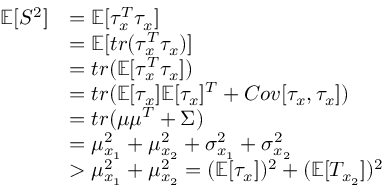<formula> <loc_0><loc_0><loc_500><loc_500>\begin{array} { r l } { \mathbb { E } [ S ^ { 2 } ] } & { = \mathbb { E } [ \tau _ { x } ^ { T } \tau _ { x } ] } \\ & { = \mathbb { E } [ t r ( \tau _ { x } ^ { T } \tau _ { x } ) ] } \\ & { = t r ( \mathbb { E } [ \tau _ { x } ^ { T } \tau _ { x } ] ) } \\ & { = t r ( \mathbb { E } [ \tau _ { x } ] \mathbb { E } [ \tau _ { x } ] ^ { T } + C o v [ \tau _ { x } , \tau _ { x } ] ) } \\ & { = t r ( \mu \mu ^ { T } + \Sigma ) } \\ & { = \mu _ { x _ { 1 } } ^ { 2 } + \mu _ { x _ { 2 } } ^ { 2 } + \sigma _ { x _ { 1 } } ^ { 2 } + \sigma _ { x _ { 2 } } ^ { 2 } } \\ & { > \mu _ { x _ { 1 } } ^ { 2 } + \mu _ { x _ { 2 } } ^ { 2 } = ( \mathbb { E } [ \tau _ { x } ] ) ^ { 2 } + ( \mathbb { E } [ T _ { x _ { 2 } } ] ) ^ { 2 } } \end{array}</formula> 